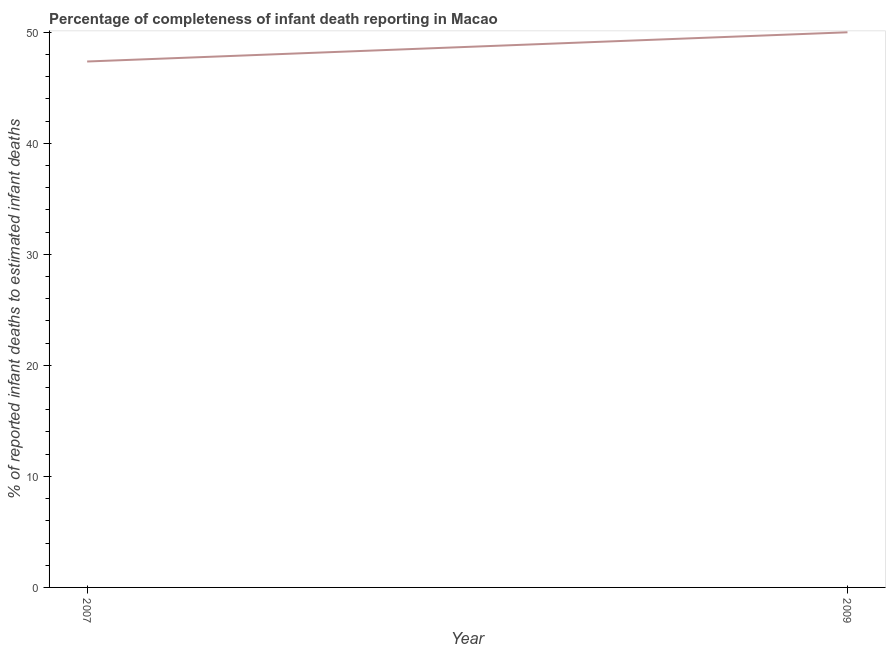What is the completeness of infant death reporting in 2007?
Make the answer very short. 47.37. Across all years, what is the maximum completeness of infant death reporting?
Provide a succinct answer. 50. Across all years, what is the minimum completeness of infant death reporting?
Your answer should be compact. 47.37. In which year was the completeness of infant death reporting maximum?
Your answer should be compact. 2009. What is the sum of the completeness of infant death reporting?
Your response must be concise. 97.37. What is the difference between the completeness of infant death reporting in 2007 and 2009?
Give a very brief answer. -2.63. What is the average completeness of infant death reporting per year?
Provide a short and direct response. 48.68. What is the median completeness of infant death reporting?
Provide a short and direct response. 48.68. What is the ratio of the completeness of infant death reporting in 2007 to that in 2009?
Ensure brevity in your answer.  0.95. Is the completeness of infant death reporting in 2007 less than that in 2009?
Provide a succinct answer. Yes. How many lines are there?
Provide a short and direct response. 1. How many years are there in the graph?
Ensure brevity in your answer.  2. Are the values on the major ticks of Y-axis written in scientific E-notation?
Provide a succinct answer. No. Does the graph contain any zero values?
Your answer should be compact. No. What is the title of the graph?
Give a very brief answer. Percentage of completeness of infant death reporting in Macao. What is the label or title of the X-axis?
Offer a terse response. Year. What is the label or title of the Y-axis?
Provide a short and direct response. % of reported infant deaths to estimated infant deaths. What is the % of reported infant deaths to estimated infant deaths in 2007?
Your answer should be very brief. 47.37. What is the difference between the % of reported infant deaths to estimated infant deaths in 2007 and 2009?
Your answer should be compact. -2.63. What is the ratio of the % of reported infant deaths to estimated infant deaths in 2007 to that in 2009?
Give a very brief answer. 0.95. 